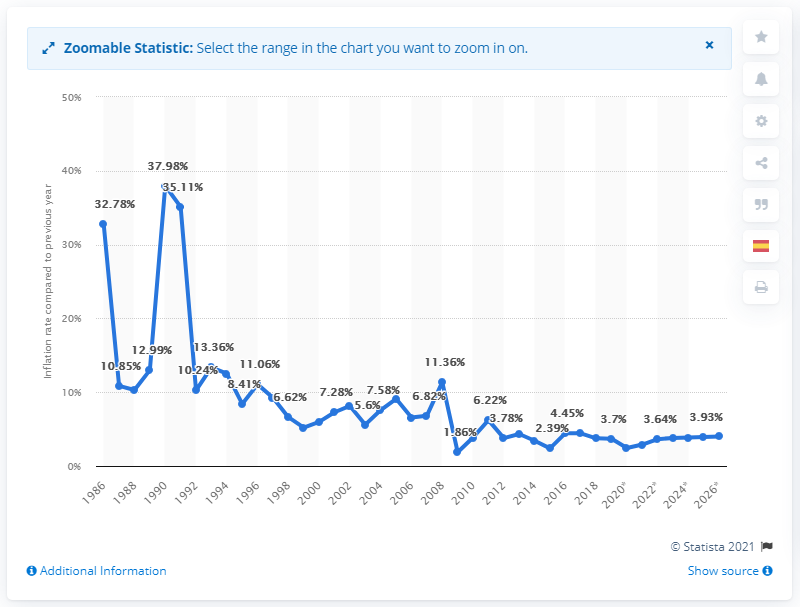Mention a couple of crucial points in this snapshot. In 2019, the inflation rate in Guatemala was 3.7%. 